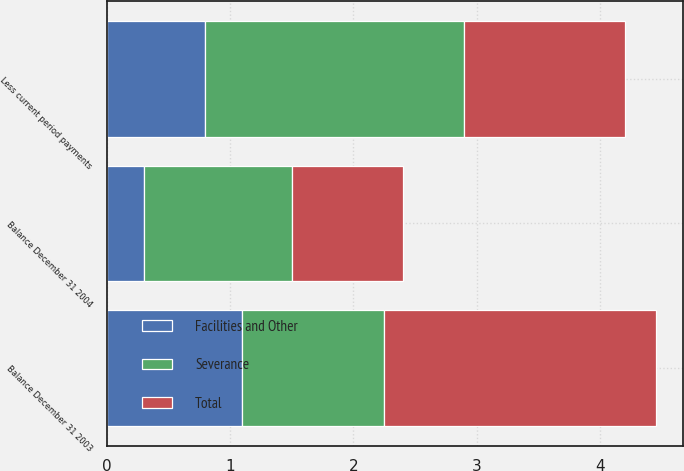Convert chart. <chart><loc_0><loc_0><loc_500><loc_500><stacked_bar_chart><ecel><fcel>Balance December 31 2003<fcel>Less current period payments<fcel>Balance December 31 2004<nl><fcel>Facilities and Other<fcel>1.1<fcel>0.8<fcel>0.3<nl><fcel>Total<fcel>2.2<fcel>1.3<fcel>0.9<nl><fcel>Severance<fcel>1.15<fcel>2.1<fcel>1.2<nl></chart> 